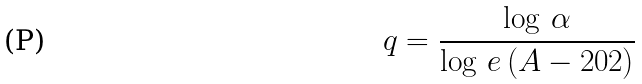<formula> <loc_0><loc_0><loc_500><loc_500>q = \frac { \log \, \alpha } { \log \, e \, ( A - 2 0 2 ) }</formula> 